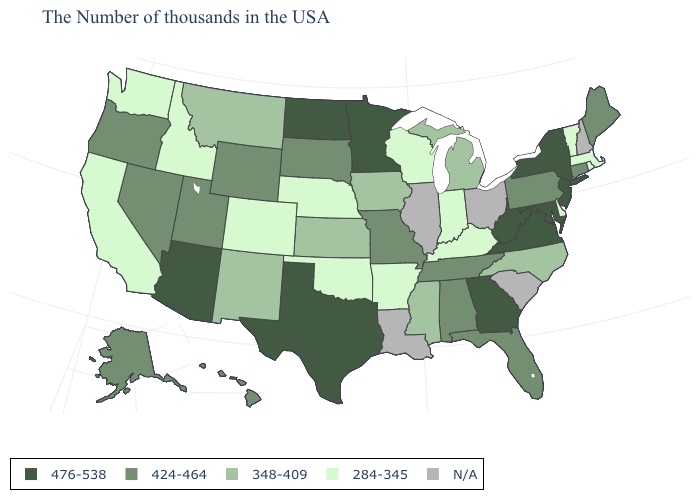What is the value of Massachusetts?
Write a very short answer. 284-345. What is the value of Minnesota?
Give a very brief answer. 476-538. What is the highest value in the MidWest ?
Short answer required. 476-538. What is the value of North Dakota?
Concise answer only. 476-538. Does Virginia have the highest value in the USA?
Be succinct. Yes. Name the states that have a value in the range 348-409?
Give a very brief answer. North Carolina, Michigan, Mississippi, Iowa, Kansas, New Mexico, Montana. What is the highest value in the MidWest ?
Give a very brief answer. 476-538. What is the value of Kentucky?
Short answer required. 284-345. What is the lowest value in the USA?
Short answer required. 284-345. Name the states that have a value in the range N/A?
Give a very brief answer. New Hampshire, South Carolina, Ohio, Illinois, Louisiana. Does the map have missing data?
Give a very brief answer. Yes. Does the first symbol in the legend represent the smallest category?
Concise answer only. No. What is the value of Wyoming?
Keep it brief. 424-464. Name the states that have a value in the range N/A?
Write a very short answer. New Hampshire, South Carolina, Ohio, Illinois, Louisiana. Does the map have missing data?
Quick response, please. Yes. 